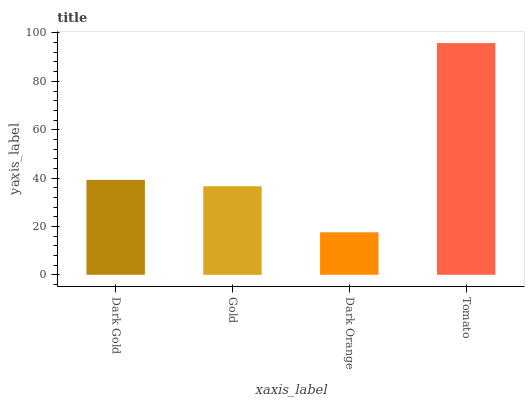Is Dark Orange the minimum?
Answer yes or no. Yes. Is Tomato the maximum?
Answer yes or no. Yes. Is Gold the minimum?
Answer yes or no. No. Is Gold the maximum?
Answer yes or no. No. Is Dark Gold greater than Gold?
Answer yes or no. Yes. Is Gold less than Dark Gold?
Answer yes or no. Yes. Is Gold greater than Dark Gold?
Answer yes or no. No. Is Dark Gold less than Gold?
Answer yes or no. No. Is Dark Gold the high median?
Answer yes or no. Yes. Is Gold the low median?
Answer yes or no. Yes. Is Tomato the high median?
Answer yes or no. No. Is Dark Gold the low median?
Answer yes or no. No. 